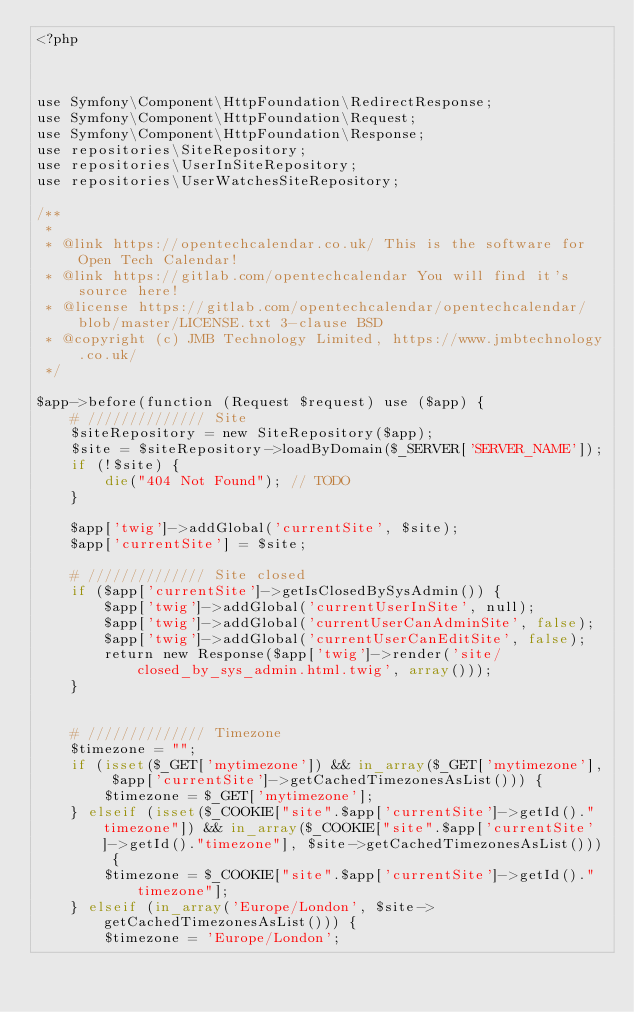Convert code to text. <code><loc_0><loc_0><loc_500><loc_500><_PHP_><?php



use Symfony\Component\HttpFoundation\RedirectResponse;
use Symfony\Component\HttpFoundation\Request;
use Symfony\Component\HttpFoundation\Response;
use repositories\SiteRepository;
use repositories\UserInSiteRepository;
use repositories\UserWatchesSiteRepository;

/**
 *
 * @link https://opentechcalendar.co.uk/ This is the software for Open Tech Calendar!
 * @link https://gitlab.com/opentechcalendar You will find it's source here!
 * @license https://gitlab.com/opentechcalendar/opentechcalendar/blob/master/LICENSE.txt 3-clause BSD
 * @copyright (c) JMB Technology Limited, https://www.jmbtechnology.co.uk/
 */

$app->before(function (Request $request) use ($app) {
    # ////////////// Site
    $siteRepository = new SiteRepository($app);
    $site = $siteRepository->loadByDomain($_SERVER['SERVER_NAME']);
    if (!$site) {
        die("404 Not Found"); // TODO
    }
    
    $app['twig']->addGlobal('currentSite', $site);
    $app['currentSite'] = $site;
    
    # ////////////// Site closed
    if ($app['currentSite']->getIsClosedBySysAdmin()) {
        $app['twig']->addGlobal('currentUserInSite', null);
        $app['twig']->addGlobal('currentUserCanAdminSite', false);
        $app['twig']->addGlobal('currentUserCanEditSite', false);
        return new Response($app['twig']->render('site/closed_by_sys_admin.html.twig', array()));
    }
    
    
    # ////////////// Timezone
    $timezone = "";
    if (isset($_GET['mytimezone']) && in_array($_GET['mytimezone'], $app['currentSite']->getCachedTimezonesAsList())) {
        $timezone = $_GET['mytimezone'];
    } elseif (isset($_COOKIE["site".$app['currentSite']->getId()."timezone"]) && in_array($_COOKIE["site".$app['currentSite']->getId()."timezone"], $site->getCachedTimezonesAsList())) {
        $timezone = $_COOKIE["site".$app['currentSite']->getId()."timezone"];
    } elseif (in_array('Europe/London', $site->getCachedTimezonesAsList())) {
        $timezone = 'Europe/London';</code> 